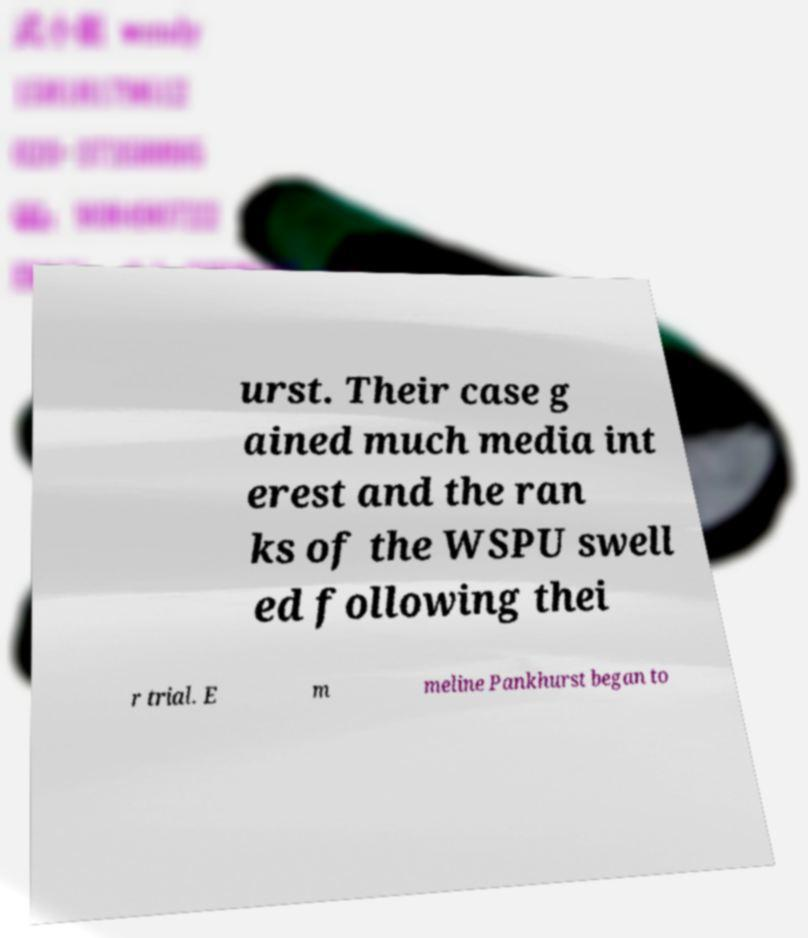Can you accurately transcribe the text from the provided image for me? urst. Their case g ained much media int erest and the ran ks of the WSPU swell ed following thei r trial. E m meline Pankhurst began to 